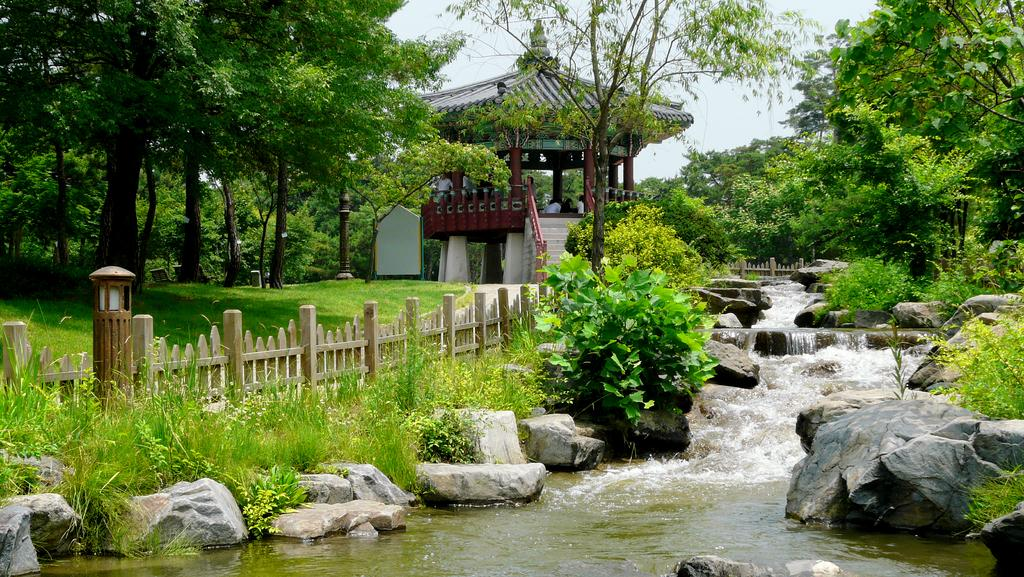What can be seen in the sky in the image? The sky is visible in the image, but no specific details about the sky can be determined from the provided facts. What type of vegetation is present in the image? There are trees and grass in the image. What is the material of the fence in the image? The fence in the image is made of wood. What is the water feature in the image? Water is visible in the image, but no specific details about the water feature can be determined from the provided facts. What type of terrain is present in the image? Rocks are present in the image, indicating a rocky terrain. Where are the people located in the image? There are people under a roof in the image. Can you tell me the name of the girl who is petting the show in the image? There is no girl, pet, or show present in the image. 